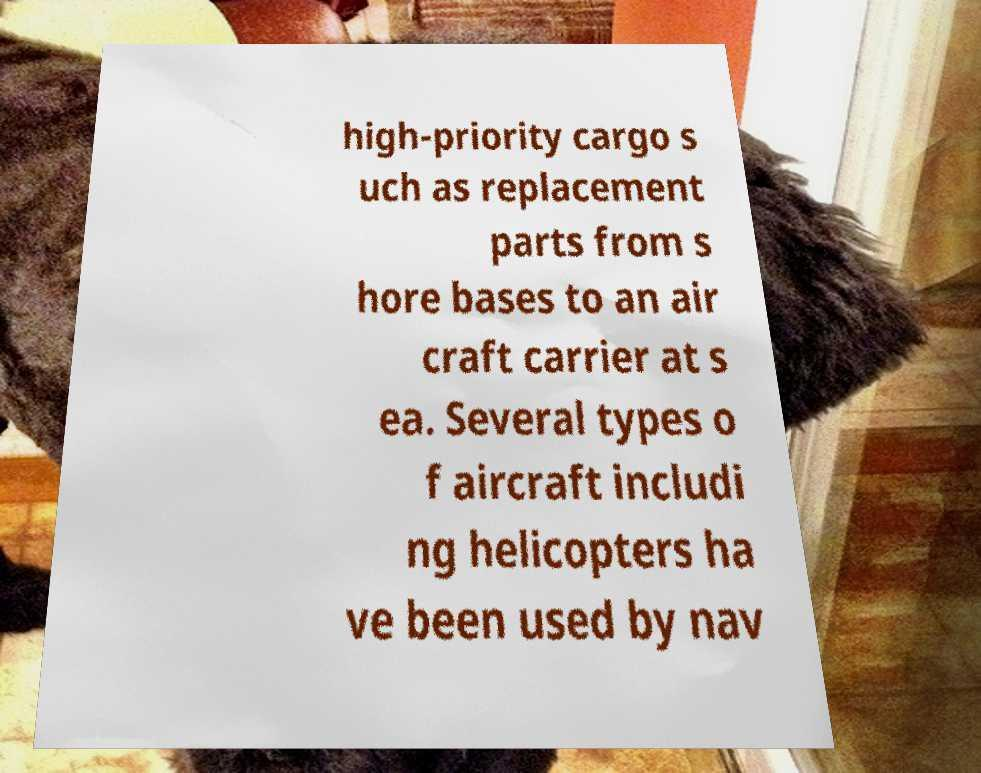Could you assist in decoding the text presented in this image and type it out clearly? high-priority cargo s uch as replacement parts from s hore bases to an air craft carrier at s ea. Several types o f aircraft includi ng helicopters ha ve been used by nav 